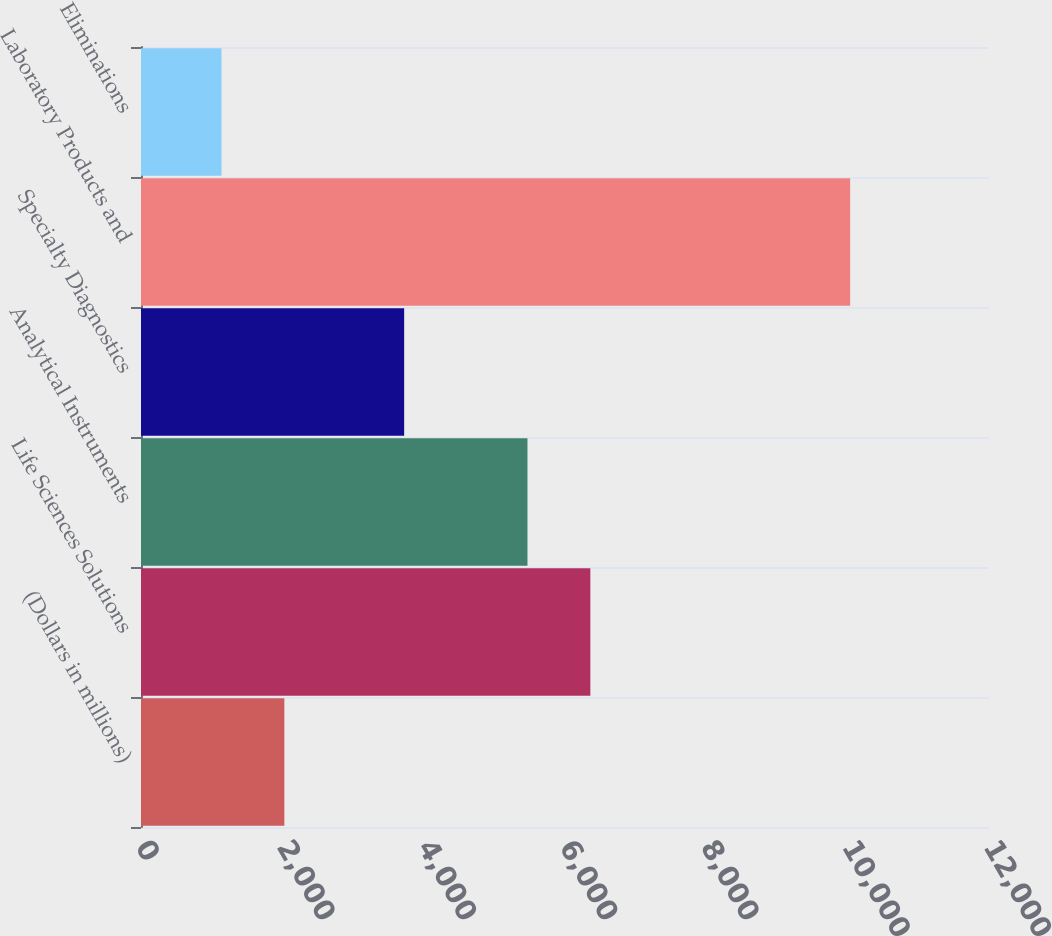Convert chart. <chart><loc_0><loc_0><loc_500><loc_500><bar_chart><fcel>(Dollars in millions)<fcel>Life Sciences Solutions<fcel>Analytical Instruments<fcel>Specialty Diagnostics<fcel>Laboratory Products and<fcel>Eliminations<nl><fcel>2028.6<fcel>6358.6<fcel>5469<fcel>3724<fcel>10035<fcel>1139<nl></chart> 